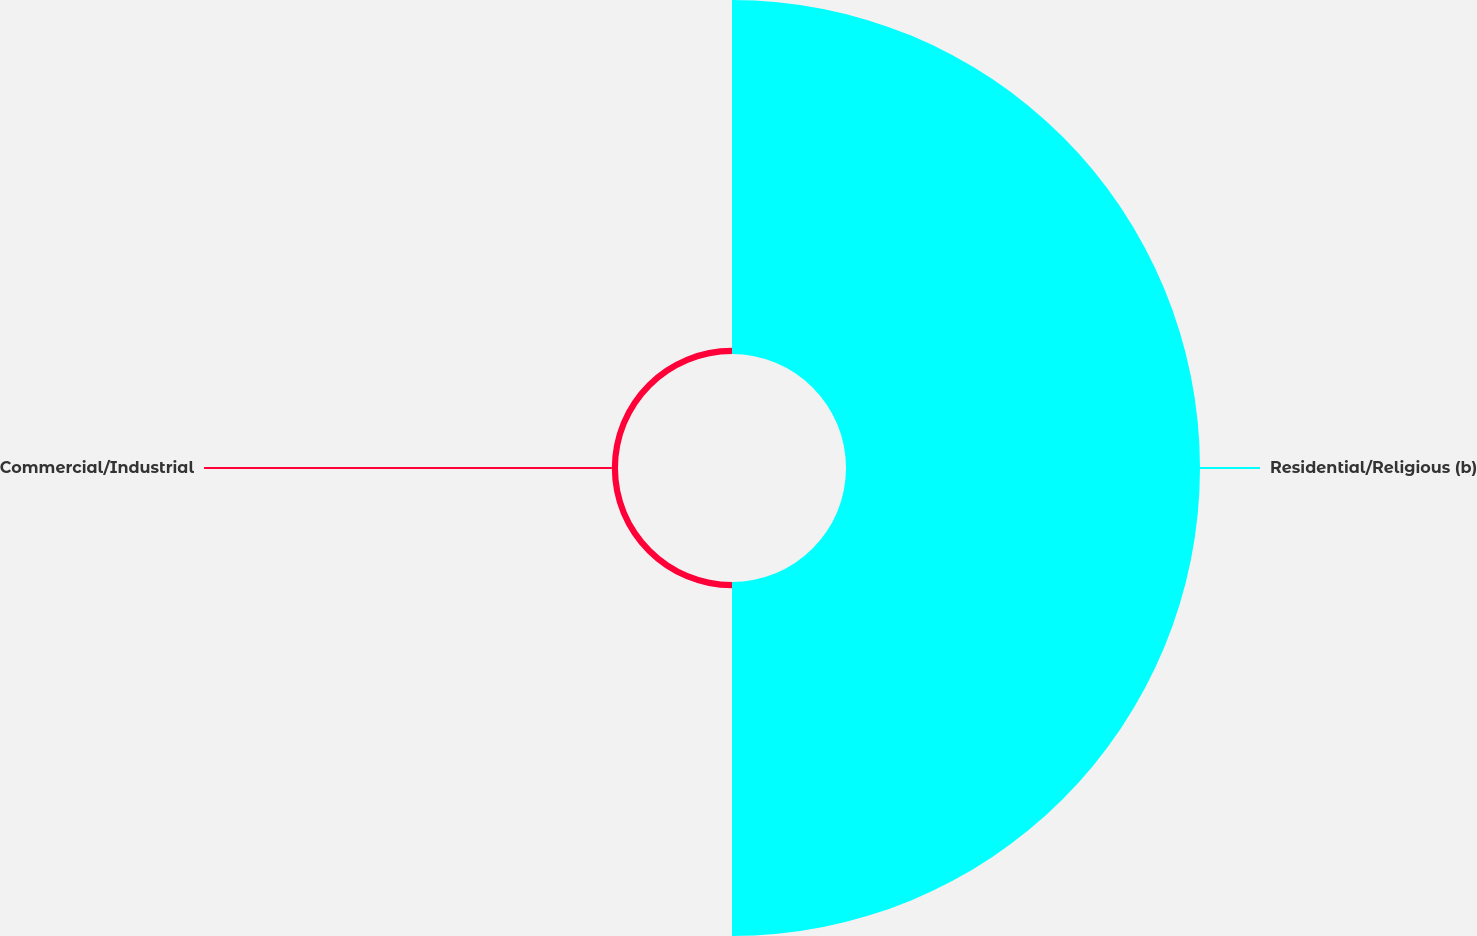Convert chart. <chart><loc_0><loc_0><loc_500><loc_500><pie_chart><fcel>Residential/Religious (b)<fcel>Commercial/Industrial<nl><fcel>98.28%<fcel>1.72%<nl></chart> 